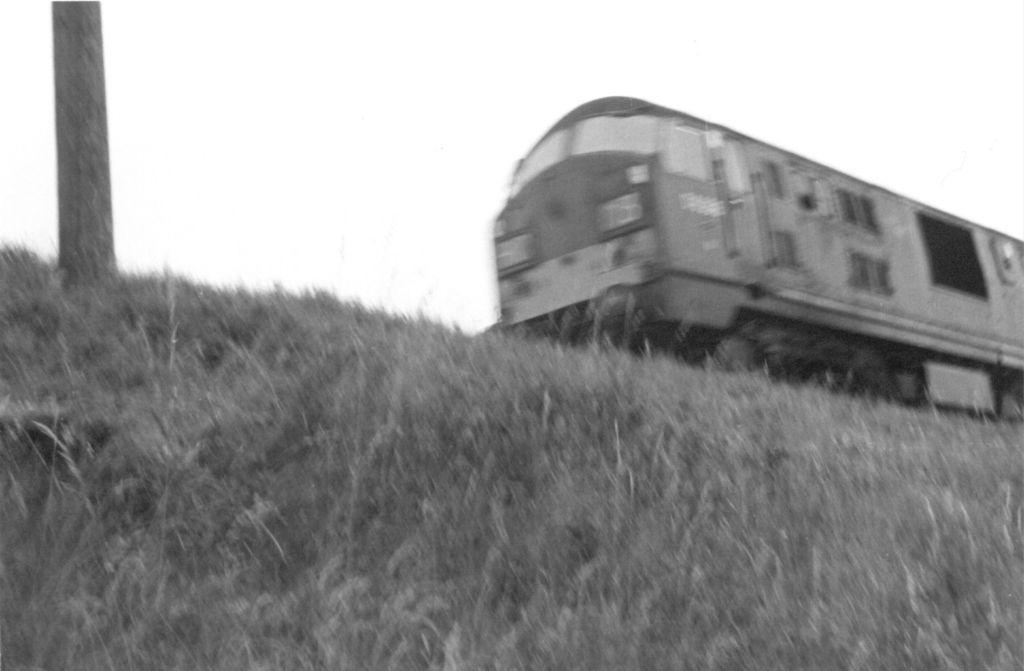How would you summarize this image in a sentence or two? In the picture we can see a grass surface with grass plants on it and on the top of it, we can see some pole and beside it we can see a train. 